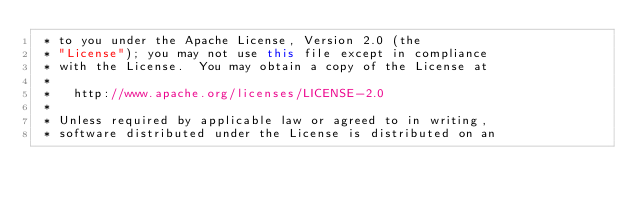Convert code to text. <code><loc_0><loc_0><loc_500><loc_500><_Java_> * to you under the Apache License, Version 2.0 (the
 * "License"); you may not use this file except in compliance
 * with the License.  You may obtain a copy of the License at
 *
 *   http://www.apache.org/licenses/LICENSE-2.0
 *
 * Unless required by applicable law or agreed to in writing,
 * software distributed under the License is distributed on an</code> 